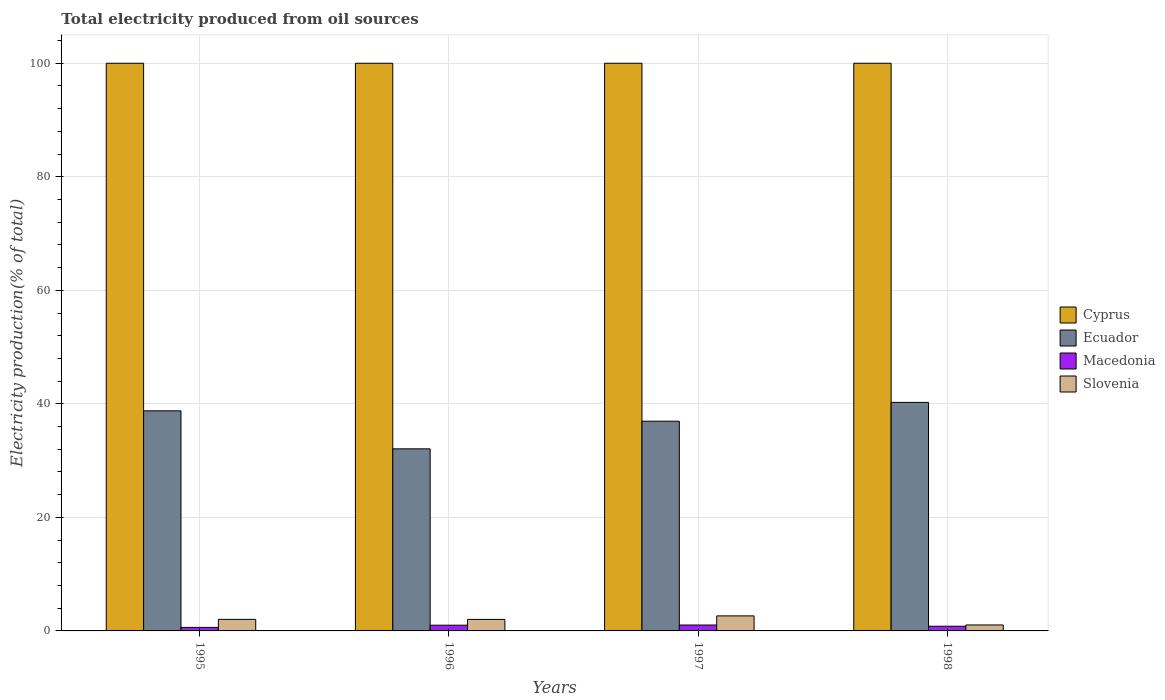How many groups of bars are there?
Make the answer very short. 4. Are the number of bars on each tick of the X-axis equal?
Provide a short and direct response. Yes. How many bars are there on the 1st tick from the left?
Offer a terse response. 4. How many bars are there on the 3rd tick from the right?
Keep it short and to the point. 4. What is the total electricity produced in Ecuador in 1998?
Your answer should be very brief. 40.26. Across all years, what is the maximum total electricity produced in Cyprus?
Give a very brief answer. 100. Across all years, what is the minimum total electricity produced in Macedonia?
Keep it short and to the point. 0.62. In which year was the total electricity produced in Cyprus minimum?
Ensure brevity in your answer.  1995. What is the total total electricity produced in Ecuador in the graph?
Provide a succinct answer. 148.05. What is the difference between the total electricity produced in Macedonia in 1996 and that in 1998?
Provide a short and direct response. 0.19. What is the difference between the total electricity produced in Ecuador in 1997 and the total electricity produced in Slovenia in 1996?
Ensure brevity in your answer.  34.91. What is the average total electricity produced in Cyprus per year?
Your answer should be very brief. 100. In the year 1996, what is the difference between the total electricity produced in Cyprus and total electricity produced in Macedonia?
Your answer should be compact. 98.99. In how many years, is the total electricity produced in Slovenia greater than 28 %?
Offer a terse response. 0. What is the ratio of the total electricity produced in Ecuador in 1996 to that in 1998?
Provide a short and direct response. 0.8. What is the difference between the highest and the second highest total electricity produced in Slovenia?
Ensure brevity in your answer.  0.61. What is the difference between the highest and the lowest total electricity produced in Cyprus?
Make the answer very short. 0. In how many years, is the total electricity produced in Cyprus greater than the average total electricity produced in Cyprus taken over all years?
Ensure brevity in your answer.  0. Is the sum of the total electricity produced in Ecuador in 1995 and 1996 greater than the maximum total electricity produced in Slovenia across all years?
Your answer should be very brief. Yes. Is it the case that in every year, the sum of the total electricity produced in Slovenia and total electricity produced in Cyprus is greater than the sum of total electricity produced in Ecuador and total electricity produced in Macedonia?
Ensure brevity in your answer.  Yes. What does the 3rd bar from the left in 1998 represents?
Your response must be concise. Macedonia. What does the 3rd bar from the right in 1995 represents?
Offer a terse response. Ecuador. Are all the bars in the graph horizontal?
Give a very brief answer. No. How many years are there in the graph?
Provide a succinct answer. 4. What is the difference between two consecutive major ticks on the Y-axis?
Provide a short and direct response. 20. Are the values on the major ticks of Y-axis written in scientific E-notation?
Make the answer very short. No. Does the graph contain any zero values?
Make the answer very short. No. Does the graph contain grids?
Give a very brief answer. Yes. How are the legend labels stacked?
Your answer should be very brief. Vertical. What is the title of the graph?
Provide a short and direct response. Total electricity produced from oil sources. Does "High income: OECD" appear as one of the legend labels in the graph?
Keep it short and to the point. No. What is the label or title of the X-axis?
Make the answer very short. Years. What is the Electricity production(% of total) in Cyprus in 1995?
Your response must be concise. 100. What is the Electricity production(% of total) of Ecuador in 1995?
Your answer should be very brief. 38.77. What is the Electricity production(% of total) of Macedonia in 1995?
Provide a short and direct response. 0.62. What is the Electricity production(% of total) of Slovenia in 1995?
Your answer should be compact. 2.04. What is the Electricity production(% of total) of Cyprus in 1996?
Give a very brief answer. 100. What is the Electricity production(% of total) of Ecuador in 1996?
Provide a succinct answer. 32.08. What is the Electricity production(% of total) of Macedonia in 1996?
Your answer should be compact. 1.01. What is the Electricity production(% of total) in Slovenia in 1996?
Keep it short and to the point. 2.03. What is the Electricity production(% of total) in Cyprus in 1997?
Ensure brevity in your answer.  100. What is the Electricity production(% of total) of Ecuador in 1997?
Offer a terse response. 36.94. What is the Electricity production(% of total) of Macedonia in 1997?
Your answer should be compact. 1.04. What is the Electricity production(% of total) of Slovenia in 1997?
Your answer should be very brief. 2.65. What is the Electricity production(% of total) of Cyprus in 1998?
Your answer should be compact. 100. What is the Electricity production(% of total) of Ecuador in 1998?
Your answer should be very brief. 40.26. What is the Electricity production(% of total) in Macedonia in 1998?
Keep it short and to the point. 0.82. What is the Electricity production(% of total) of Slovenia in 1998?
Ensure brevity in your answer.  1.05. Across all years, what is the maximum Electricity production(% of total) of Cyprus?
Offer a terse response. 100. Across all years, what is the maximum Electricity production(% of total) in Ecuador?
Make the answer very short. 40.26. Across all years, what is the maximum Electricity production(% of total) in Macedonia?
Make the answer very short. 1.04. Across all years, what is the maximum Electricity production(% of total) of Slovenia?
Keep it short and to the point. 2.65. Across all years, what is the minimum Electricity production(% of total) of Cyprus?
Offer a very short reply. 100. Across all years, what is the minimum Electricity production(% of total) in Ecuador?
Provide a succinct answer. 32.08. Across all years, what is the minimum Electricity production(% of total) in Macedonia?
Offer a very short reply. 0.62. Across all years, what is the minimum Electricity production(% of total) of Slovenia?
Provide a succinct answer. 1.05. What is the total Electricity production(% of total) in Ecuador in the graph?
Provide a succinct answer. 148.05. What is the total Electricity production(% of total) in Macedonia in the graph?
Give a very brief answer. 3.49. What is the total Electricity production(% of total) in Slovenia in the graph?
Offer a very short reply. 7.76. What is the difference between the Electricity production(% of total) in Ecuador in 1995 and that in 1996?
Your response must be concise. 6.69. What is the difference between the Electricity production(% of total) of Macedonia in 1995 and that in 1996?
Make the answer very short. -0.39. What is the difference between the Electricity production(% of total) of Slovenia in 1995 and that in 1996?
Provide a short and direct response. 0.01. What is the difference between the Electricity production(% of total) in Ecuador in 1995 and that in 1997?
Your answer should be very brief. 1.83. What is the difference between the Electricity production(% of total) in Macedonia in 1995 and that in 1997?
Make the answer very short. -0.42. What is the difference between the Electricity production(% of total) of Slovenia in 1995 and that in 1997?
Keep it short and to the point. -0.61. What is the difference between the Electricity production(% of total) of Ecuador in 1995 and that in 1998?
Your answer should be compact. -1.49. What is the difference between the Electricity production(% of total) in Macedonia in 1995 and that in 1998?
Your answer should be compact. -0.2. What is the difference between the Electricity production(% of total) of Slovenia in 1995 and that in 1998?
Keep it short and to the point. 0.99. What is the difference between the Electricity production(% of total) in Cyprus in 1996 and that in 1997?
Offer a terse response. 0. What is the difference between the Electricity production(% of total) in Ecuador in 1996 and that in 1997?
Your response must be concise. -4.87. What is the difference between the Electricity production(% of total) of Macedonia in 1996 and that in 1997?
Offer a very short reply. -0.03. What is the difference between the Electricity production(% of total) of Slovenia in 1996 and that in 1997?
Ensure brevity in your answer.  -0.62. What is the difference between the Electricity production(% of total) in Cyprus in 1996 and that in 1998?
Provide a succinct answer. 0. What is the difference between the Electricity production(% of total) of Ecuador in 1996 and that in 1998?
Make the answer very short. -8.18. What is the difference between the Electricity production(% of total) in Macedonia in 1996 and that in 1998?
Keep it short and to the point. 0.19. What is the difference between the Electricity production(% of total) in Slovenia in 1996 and that in 1998?
Give a very brief answer. 0.98. What is the difference between the Electricity production(% of total) of Ecuador in 1997 and that in 1998?
Your response must be concise. -3.31. What is the difference between the Electricity production(% of total) of Macedonia in 1997 and that in 1998?
Provide a short and direct response. 0.22. What is the difference between the Electricity production(% of total) of Slovenia in 1997 and that in 1998?
Give a very brief answer. 1.6. What is the difference between the Electricity production(% of total) of Cyprus in 1995 and the Electricity production(% of total) of Ecuador in 1996?
Offer a very short reply. 67.92. What is the difference between the Electricity production(% of total) of Cyprus in 1995 and the Electricity production(% of total) of Macedonia in 1996?
Your answer should be compact. 98.99. What is the difference between the Electricity production(% of total) in Cyprus in 1995 and the Electricity production(% of total) in Slovenia in 1996?
Offer a terse response. 97.97. What is the difference between the Electricity production(% of total) in Ecuador in 1995 and the Electricity production(% of total) in Macedonia in 1996?
Make the answer very short. 37.76. What is the difference between the Electricity production(% of total) of Ecuador in 1995 and the Electricity production(% of total) of Slovenia in 1996?
Give a very brief answer. 36.74. What is the difference between the Electricity production(% of total) of Macedonia in 1995 and the Electricity production(% of total) of Slovenia in 1996?
Ensure brevity in your answer.  -1.41. What is the difference between the Electricity production(% of total) of Cyprus in 1995 and the Electricity production(% of total) of Ecuador in 1997?
Offer a very short reply. 63.06. What is the difference between the Electricity production(% of total) of Cyprus in 1995 and the Electricity production(% of total) of Macedonia in 1997?
Keep it short and to the point. 98.96. What is the difference between the Electricity production(% of total) of Cyprus in 1995 and the Electricity production(% of total) of Slovenia in 1997?
Provide a succinct answer. 97.35. What is the difference between the Electricity production(% of total) of Ecuador in 1995 and the Electricity production(% of total) of Macedonia in 1997?
Your answer should be very brief. 37.73. What is the difference between the Electricity production(% of total) of Ecuador in 1995 and the Electricity production(% of total) of Slovenia in 1997?
Your response must be concise. 36.12. What is the difference between the Electricity production(% of total) in Macedonia in 1995 and the Electricity production(% of total) in Slovenia in 1997?
Your answer should be very brief. -2.03. What is the difference between the Electricity production(% of total) of Cyprus in 1995 and the Electricity production(% of total) of Ecuador in 1998?
Give a very brief answer. 59.74. What is the difference between the Electricity production(% of total) of Cyprus in 1995 and the Electricity production(% of total) of Macedonia in 1998?
Your answer should be very brief. 99.18. What is the difference between the Electricity production(% of total) in Cyprus in 1995 and the Electricity production(% of total) in Slovenia in 1998?
Your answer should be very brief. 98.95. What is the difference between the Electricity production(% of total) of Ecuador in 1995 and the Electricity production(% of total) of Macedonia in 1998?
Make the answer very short. 37.95. What is the difference between the Electricity production(% of total) of Ecuador in 1995 and the Electricity production(% of total) of Slovenia in 1998?
Your answer should be compact. 37.72. What is the difference between the Electricity production(% of total) of Macedonia in 1995 and the Electricity production(% of total) of Slovenia in 1998?
Provide a succinct answer. -0.43. What is the difference between the Electricity production(% of total) of Cyprus in 1996 and the Electricity production(% of total) of Ecuador in 1997?
Provide a short and direct response. 63.06. What is the difference between the Electricity production(% of total) of Cyprus in 1996 and the Electricity production(% of total) of Macedonia in 1997?
Offer a very short reply. 98.96. What is the difference between the Electricity production(% of total) of Cyprus in 1996 and the Electricity production(% of total) of Slovenia in 1997?
Make the answer very short. 97.35. What is the difference between the Electricity production(% of total) in Ecuador in 1996 and the Electricity production(% of total) in Macedonia in 1997?
Give a very brief answer. 31.04. What is the difference between the Electricity production(% of total) in Ecuador in 1996 and the Electricity production(% of total) in Slovenia in 1997?
Your answer should be very brief. 29.43. What is the difference between the Electricity production(% of total) in Macedonia in 1996 and the Electricity production(% of total) in Slovenia in 1997?
Your answer should be very brief. -1.64. What is the difference between the Electricity production(% of total) of Cyprus in 1996 and the Electricity production(% of total) of Ecuador in 1998?
Offer a very short reply. 59.74. What is the difference between the Electricity production(% of total) in Cyprus in 1996 and the Electricity production(% of total) in Macedonia in 1998?
Your response must be concise. 99.18. What is the difference between the Electricity production(% of total) in Cyprus in 1996 and the Electricity production(% of total) in Slovenia in 1998?
Your answer should be very brief. 98.95. What is the difference between the Electricity production(% of total) of Ecuador in 1996 and the Electricity production(% of total) of Macedonia in 1998?
Make the answer very short. 31.25. What is the difference between the Electricity production(% of total) of Ecuador in 1996 and the Electricity production(% of total) of Slovenia in 1998?
Offer a terse response. 31.03. What is the difference between the Electricity production(% of total) in Macedonia in 1996 and the Electricity production(% of total) in Slovenia in 1998?
Provide a succinct answer. -0.04. What is the difference between the Electricity production(% of total) in Cyprus in 1997 and the Electricity production(% of total) in Ecuador in 1998?
Your answer should be very brief. 59.74. What is the difference between the Electricity production(% of total) of Cyprus in 1997 and the Electricity production(% of total) of Macedonia in 1998?
Your response must be concise. 99.18. What is the difference between the Electricity production(% of total) of Cyprus in 1997 and the Electricity production(% of total) of Slovenia in 1998?
Offer a terse response. 98.95. What is the difference between the Electricity production(% of total) in Ecuador in 1997 and the Electricity production(% of total) in Macedonia in 1998?
Keep it short and to the point. 36.12. What is the difference between the Electricity production(% of total) in Ecuador in 1997 and the Electricity production(% of total) in Slovenia in 1998?
Offer a terse response. 35.89. What is the difference between the Electricity production(% of total) in Macedonia in 1997 and the Electricity production(% of total) in Slovenia in 1998?
Your answer should be very brief. -0.01. What is the average Electricity production(% of total) of Cyprus per year?
Your answer should be very brief. 100. What is the average Electricity production(% of total) of Ecuador per year?
Give a very brief answer. 37.01. What is the average Electricity production(% of total) in Macedonia per year?
Ensure brevity in your answer.  0.87. What is the average Electricity production(% of total) in Slovenia per year?
Provide a short and direct response. 1.94. In the year 1995, what is the difference between the Electricity production(% of total) in Cyprus and Electricity production(% of total) in Ecuador?
Make the answer very short. 61.23. In the year 1995, what is the difference between the Electricity production(% of total) in Cyprus and Electricity production(% of total) in Macedonia?
Provide a short and direct response. 99.38. In the year 1995, what is the difference between the Electricity production(% of total) of Cyprus and Electricity production(% of total) of Slovenia?
Offer a very short reply. 97.96. In the year 1995, what is the difference between the Electricity production(% of total) of Ecuador and Electricity production(% of total) of Macedonia?
Offer a terse response. 38.15. In the year 1995, what is the difference between the Electricity production(% of total) in Ecuador and Electricity production(% of total) in Slovenia?
Provide a short and direct response. 36.73. In the year 1995, what is the difference between the Electricity production(% of total) of Macedonia and Electricity production(% of total) of Slovenia?
Ensure brevity in your answer.  -1.42. In the year 1996, what is the difference between the Electricity production(% of total) of Cyprus and Electricity production(% of total) of Ecuador?
Offer a very short reply. 67.92. In the year 1996, what is the difference between the Electricity production(% of total) in Cyprus and Electricity production(% of total) in Macedonia?
Provide a succinct answer. 98.99. In the year 1996, what is the difference between the Electricity production(% of total) of Cyprus and Electricity production(% of total) of Slovenia?
Give a very brief answer. 97.97. In the year 1996, what is the difference between the Electricity production(% of total) of Ecuador and Electricity production(% of total) of Macedonia?
Your response must be concise. 31.07. In the year 1996, what is the difference between the Electricity production(% of total) of Ecuador and Electricity production(% of total) of Slovenia?
Offer a terse response. 30.05. In the year 1996, what is the difference between the Electricity production(% of total) in Macedonia and Electricity production(% of total) in Slovenia?
Give a very brief answer. -1.02. In the year 1997, what is the difference between the Electricity production(% of total) in Cyprus and Electricity production(% of total) in Ecuador?
Provide a succinct answer. 63.06. In the year 1997, what is the difference between the Electricity production(% of total) of Cyprus and Electricity production(% of total) of Macedonia?
Provide a short and direct response. 98.96. In the year 1997, what is the difference between the Electricity production(% of total) in Cyprus and Electricity production(% of total) in Slovenia?
Offer a terse response. 97.35. In the year 1997, what is the difference between the Electricity production(% of total) in Ecuador and Electricity production(% of total) in Macedonia?
Offer a terse response. 35.9. In the year 1997, what is the difference between the Electricity production(% of total) in Ecuador and Electricity production(% of total) in Slovenia?
Offer a very short reply. 34.29. In the year 1997, what is the difference between the Electricity production(% of total) of Macedonia and Electricity production(% of total) of Slovenia?
Keep it short and to the point. -1.61. In the year 1998, what is the difference between the Electricity production(% of total) of Cyprus and Electricity production(% of total) of Ecuador?
Offer a very short reply. 59.74. In the year 1998, what is the difference between the Electricity production(% of total) of Cyprus and Electricity production(% of total) of Macedonia?
Give a very brief answer. 99.18. In the year 1998, what is the difference between the Electricity production(% of total) of Cyprus and Electricity production(% of total) of Slovenia?
Ensure brevity in your answer.  98.95. In the year 1998, what is the difference between the Electricity production(% of total) in Ecuador and Electricity production(% of total) in Macedonia?
Offer a terse response. 39.43. In the year 1998, what is the difference between the Electricity production(% of total) of Ecuador and Electricity production(% of total) of Slovenia?
Your answer should be very brief. 39.21. In the year 1998, what is the difference between the Electricity production(% of total) of Macedonia and Electricity production(% of total) of Slovenia?
Offer a very short reply. -0.23. What is the ratio of the Electricity production(% of total) in Cyprus in 1995 to that in 1996?
Keep it short and to the point. 1. What is the ratio of the Electricity production(% of total) in Ecuador in 1995 to that in 1996?
Provide a succinct answer. 1.21. What is the ratio of the Electricity production(% of total) of Macedonia in 1995 to that in 1996?
Your answer should be compact. 0.61. What is the ratio of the Electricity production(% of total) in Slovenia in 1995 to that in 1996?
Your answer should be compact. 1. What is the ratio of the Electricity production(% of total) in Cyprus in 1995 to that in 1997?
Give a very brief answer. 1. What is the ratio of the Electricity production(% of total) in Ecuador in 1995 to that in 1997?
Offer a terse response. 1.05. What is the ratio of the Electricity production(% of total) in Macedonia in 1995 to that in 1997?
Provide a short and direct response. 0.6. What is the ratio of the Electricity production(% of total) of Slovenia in 1995 to that in 1997?
Give a very brief answer. 0.77. What is the ratio of the Electricity production(% of total) of Cyprus in 1995 to that in 1998?
Your answer should be very brief. 1. What is the ratio of the Electricity production(% of total) in Ecuador in 1995 to that in 1998?
Your answer should be very brief. 0.96. What is the ratio of the Electricity production(% of total) in Macedonia in 1995 to that in 1998?
Your answer should be compact. 0.75. What is the ratio of the Electricity production(% of total) in Slovenia in 1995 to that in 1998?
Make the answer very short. 1.94. What is the ratio of the Electricity production(% of total) of Cyprus in 1996 to that in 1997?
Your answer should be very brief. 1. What is the ratio of the Electricity production(% of total) of Ecuador in 1996 to that in 1997?
Provide a succinct answer. 0.87. What is the ratio of the Electricity production(% of total) of Macedonia in 1996 to that in 1997?
Offer a terse response. 0.97. What is the ratio of the Electricity production(% of total) of Slovenia in 1996 to that in 1997?
Provide a succinct answer. 0.77. What is the ratio of the Electricity production(% of total) of Ecuador in 1996 to that in 1998?
Keep it short and to the point. 0.8. What is the ratio of the Electricity production(% of total) of Macedonia in 1996 to that in 1998?
Offer a terse response. 1.23. What is the ratio of the Electricity production(% of total) in Slovenia in 1996 to that in 1998?
Offer a very short reply. 1.93. What is the ratio of the Electricity production(% of total) in Ecuador in 1997 to that in 1998?
Your answer should be very brief. 0.92. What is the ratio of the Electricity production(% of total) of Macedonia in 1997 to that in 1998?
Give a very brief answer. 1.26. What is the ratio of the Electricity production(% of total) of Slovenia in 1997 to that in 1998?
Provide a short and direct response. 2.53. What is the difference between the highest and the second highest Electricity production(% of total) of Ecuador?
Give a very brief answer. 1.49. What is the difference between the highest and the second highest Electricity production(% of total) in Macedonia?
Ensure brevity in your answer.  0.03. What is the difference between the highest and the second highest Electricity production(% of total) in Slovenia?
Give a very brief answer. 0.61. What is the difference between the highest and the lowest Electricity production(% of total) of Cyprus?
Your answer should be very brief. 0. What is the difference between the highest and the lowest Electricity production(% of total) in Ecuador?
Your response must be concise. 8.18. What is the difference between the highest and the lowest Electricity production(% of total) in Macedonia?
Offer a very short reply. 0.42. What is the difference between the highest and the lowest Electricity production(% of total) of Slovenia?
Your answer should be very brief. 1.6. 